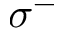<formula> <loc_0><loc_0><loc_500><loc_500>\sigma ^ { - }</formula> 